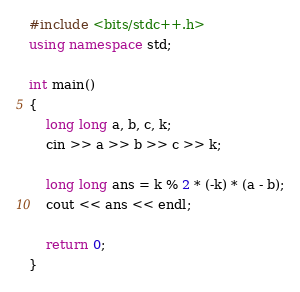<code> <loc_0><loc_0><loc_500><loc_500><_C++_>#include <bits/stdc++.h>
using namespace std;

int main()
{
    long long a, b, c, k;
    cin >> a >> b >> c >> k;

    long long ans = k % 2 * (-k) * (a - b);
    cout << ans << endl;

    return 0;
}
</code> 